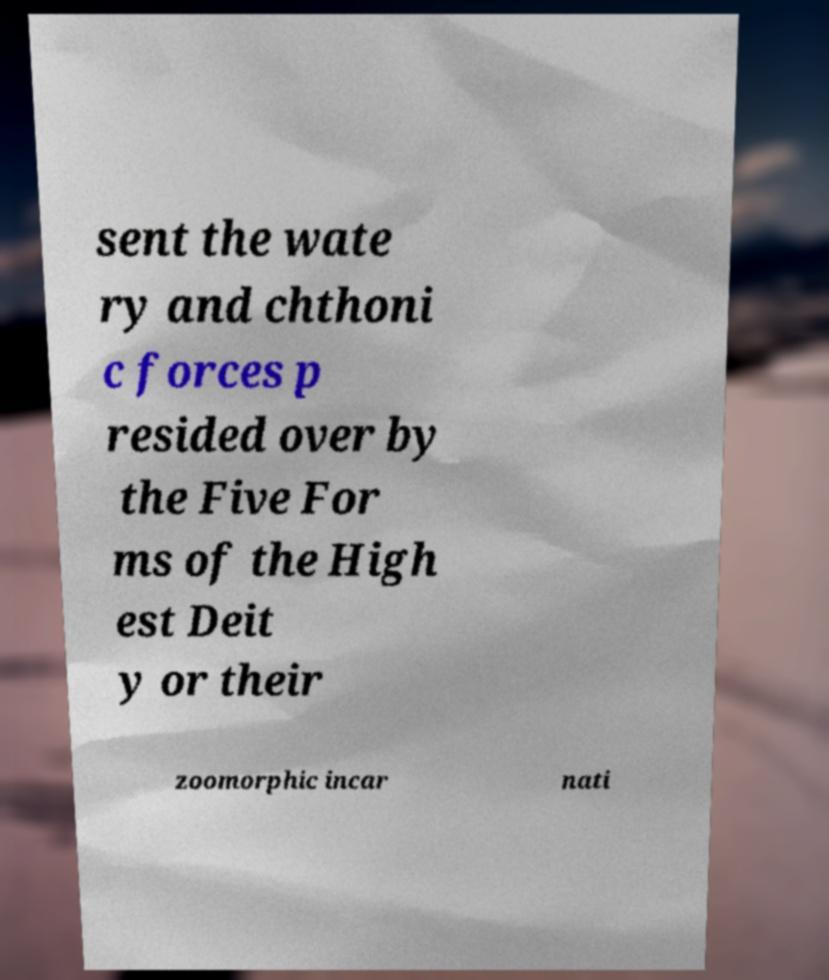What messages or text are displayed in this image? I need them in a readable, typed format. sent the wate ry and chthoni c forces p resided over by the Five For ms of the High est Deit y or their zoomorphic incar nati 